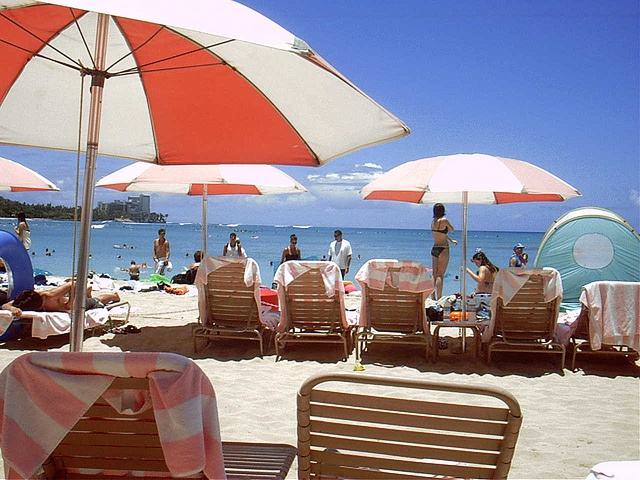Describe the objects in this image and their specific colors. I can see umbrella in lightgray, red, and brown tones, chair in lightgray, brown, and maroon tones, chair in lightgray, maroon, ivory, and brown tones, umbrella in lightgray, white, salmon, tan, and brown tones, and chair in lightgray, maroon, brown, and white tones in this image. 